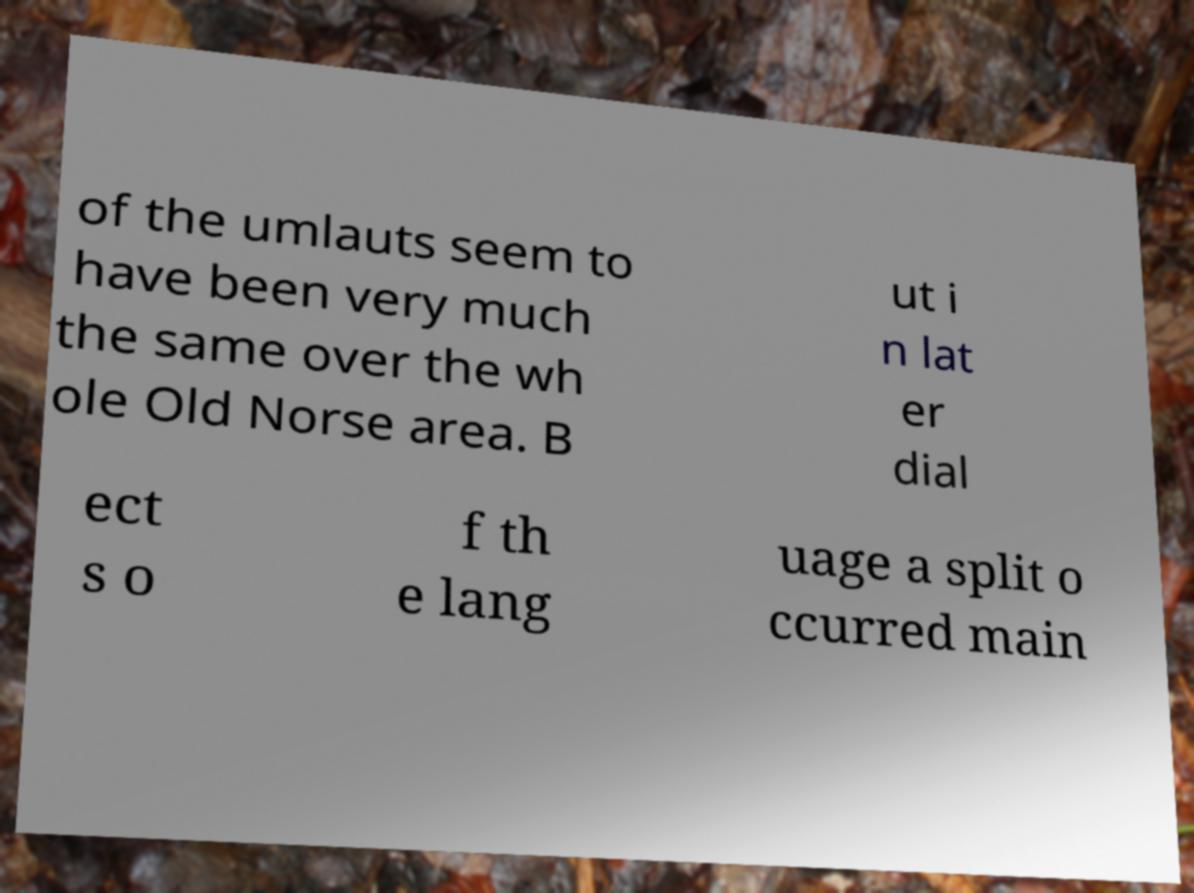There's text embedded in this image that I need extracted. Can you transcribe it verbatim? of the umlauts seem to have been very much the same over the wh ole Old Norse area. B ut i n lat er dial ect s o f th e lang uage a split o ccurred main 